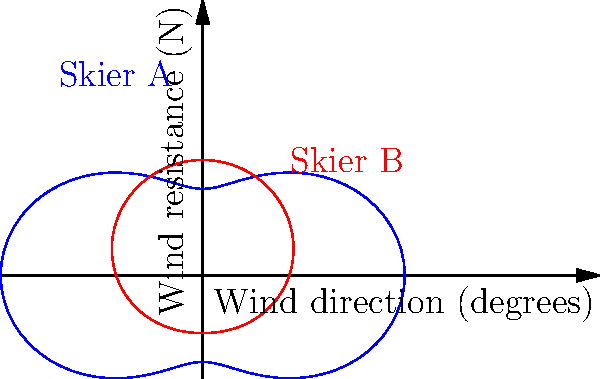The polar graph shows wind resistance data for two skiers (A and B) as they rotate through different angles relative to the wind direction. At approximately what angle does Skier A experience the maximum wind resistance, and what is this maximum value? To solve this problem, we need to analyze the blue curve representing Skier A's wind resistance:

1. The general equation for Skier A's curve is $r = 5 + 2\cos(2\theta)$, where $r$ is the wind resistance in Newtons and $\theta$ is the angle in radians.

2. To find the maximum value, we need to determine where the cosine term reaches its maximum value of 1. This occurs when $2\theta = 0$, $2\pi$, $4\pi$, etc.

3. Solving for $\theta$:
   $\theta = 0$, $\pi$, $2\pi$, etc.

4. Converting to degrees:
   $\theta = 0°$, $180°$, $360°$, etc.

5. The maximum wind resistance occurs at these angles:
   $r_{max} = 5 + 2(1) = 7$ N

6. On the graph, we can see that the blue curve reaches its maximum at 0° (and equivalently at 180°).

Therefore, Skier A experiences maximum wind resistance of 7 N at approximately 0° (or 180°) relative to the wind direction.
Answer: 0° (or 180°), 7 N 